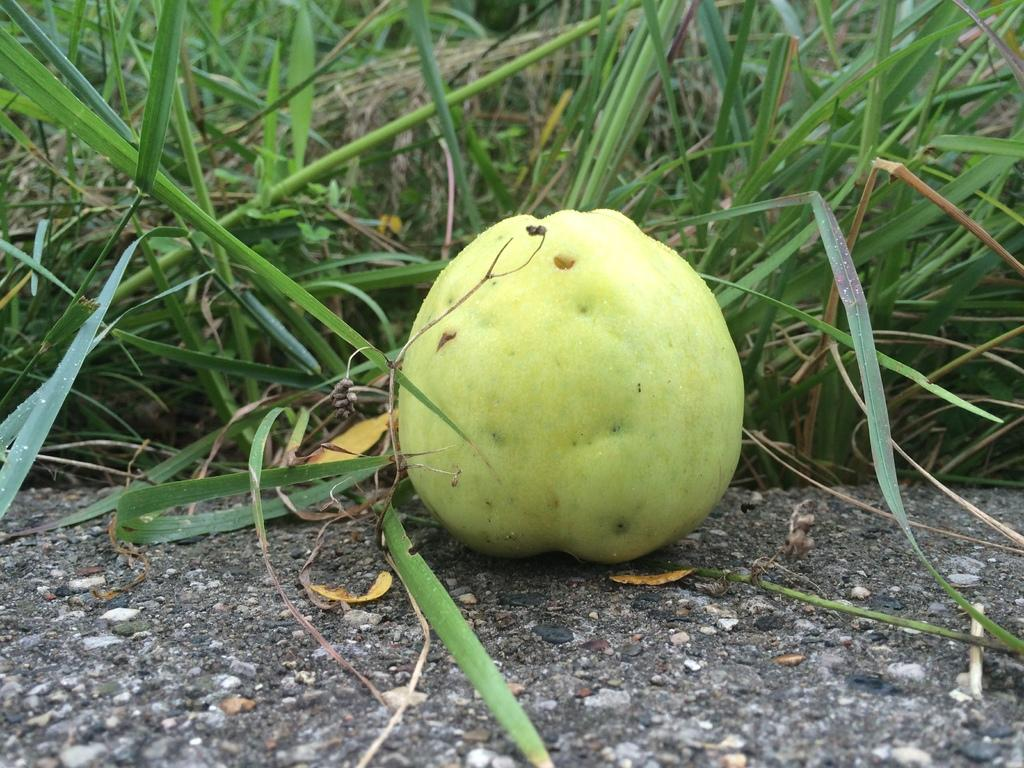What type of fruit can be seen in the image? There is a fruit in the image that resembles a guava. Where is the fruit located in the image? The fruit is on a surface, possibly a table or countertop. What can be seen at the bottom of the image? There is a road visible at the bottom of the image. What is present on the road? Stones are present on the road. What type of vegetation is visible in the background of the image? There is grass in the background of the image, and it is green in color. What word is written on the fruit in the image? There are no words written on the fruit in the image. What type of reward can be seen in the image? There is no reward present in the image. 